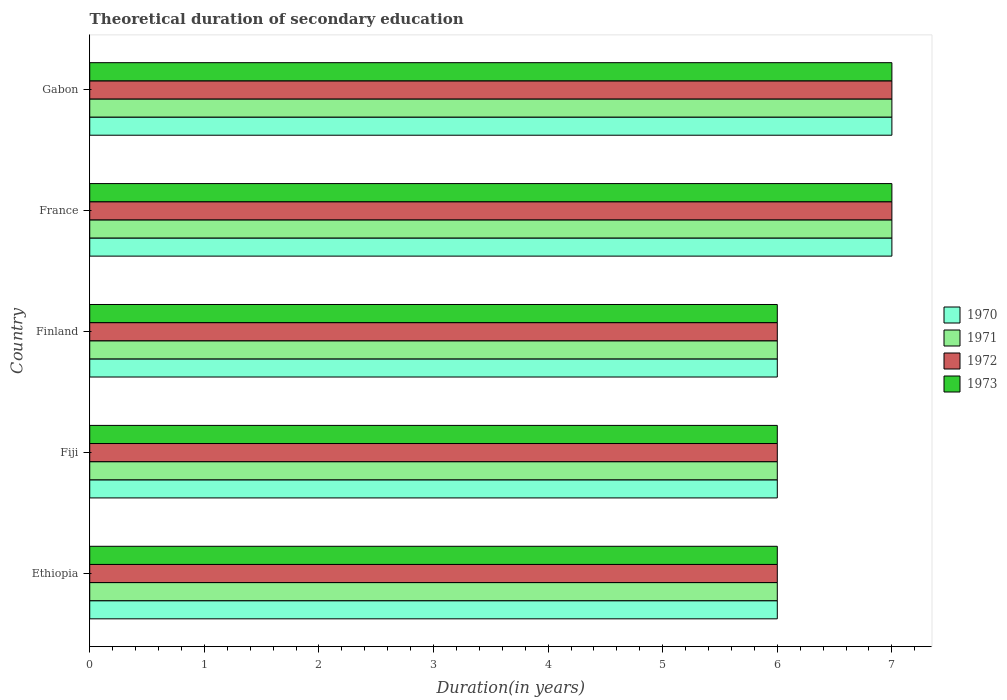How many groups of bars are there?
Your answer should be very brief. 5. Are the number of bars per tick equal to the number of legend labels?
Offer a very short reply. Yes. Are the number of bars on each tick of the Y-axis equal?
Offer a terse response. Yes. What is the label of the 5th group of bars from the top?
Your response must be concise. Ethiopia. Across all countries, what is the maximum total theoretical duration of secondary education in 1970?
Ensure brevity in your answer.  7. Across all countries, what is the minimum total theoretical duration of secondary education in 1972?
Keep it short and to the point. 6. In which country was the total theoretical duration of secondary education in 1972 maximum?
Ensure brevity in your answer.  France. In which country was the total theoretical duration of secondary education in 1970 minimum?
Give a very brief answer. Ethiopia. What is the total total theoretical duration of secondary education in 1970 in the graph?
Ensure brevity in your answer.  32. What is the average total theoretical duration of secondary education in 1972 per country?
Give a very brief answer. 6.4. What is the ratio of the total theoretical duration of secondary education in 1973 in Finland to that in Gabon?
Offer a terse response. 0.86. What is the difference between the highest and the second highest total theoretical duration of secondary education in 1973?
Keep it short and to the point. 0. In how many countries, is the total theoretical duration of secondary education in 1971 greater than the average total theoretical duration of secondary education in 1971 taken over all countries?
Provide a succinct answer. 2. How many bars are there?
Your response must be concise. 20. Are all the bars in the graph horizontal?
Offer a terse response. Yes. How many countries are there in the graph?
Provide a succinct answer. 5. Are the values on the major ticks of X-axis written in scientific E-notation?
Make the answer very short. No. Does the graph contain grids?
Offer a terse response. No. How many legend labels are there?
Make the answer very short. 4. What is the title of the graph?
Your answer should be compact. Theoretical duration of secondary education. What is the label or title of the X-axis?
Keep it short and to the point. Duration(in years). What is the label or title of the Y-axis?
Make the answer very short. Country. What is the Duration(in years) of 1971 in Ethiopia?
Your answer should be compact. 6. What is the Duration(in years) of 1972 in Ethiopia?
Your answer should be very brief. 6. What is the Duration(in years) in 1973 in Ethiopia?
Make the answer very short. 6. What is the Duration(in years) in 1970 in Fiji?
Keep it short and to the point. 6. What is the Duration(in years) in 1971 in Fiji?
Your answer should be very brief. 6. What is the Duration(in years) of 1972 in Fiji?
Ensure brevity in your answer.  6. What is the Duration(in years) in 1971 in Finland?
Provide a short and direct response. 6. What is the Duration(in years) in 1973 in Finland?
Your answer should be very brief. 6. What is the Duration(in years) in 1971 in France?
Provide a short and direct response. 7. What is the Duration(in years) of 1972 in France?
Your answer should be compact. 7. What is the Duration(in years) of 1970 in Gabon?
Make the answer very short. 7. What is the Duration(in years) of 1971 in Gabon?
Provide a short and direct response. 7. Across all countries, what is the maximum Duration(in years) of 1970?
Provide a succinct answer. 7. Across all countries, what is the maximum Duration(in years) in 1973?
Keep it short and to the point. 7. Across all countries, what is the minimum Duration(in years) of 1971?
Ensure brevity in your answer.  6. Across all countries, what is the minimum Duration(in years) of 1973?
Your response must be concise. 6. What is the total Duration(in years) in 1970 in the graph?
Your answer should be compact. 32. What is the difference between the Duration(in years) of 1972 in Ethiopia and that in Fiji?
Provide a short and direct response. 0. What is the difference between the Duration(in years) of 1971 in Ethiopia and that in Finland?
Offer a very short reply. 0. What is the difference between the Duration(in years) of 1973 in Ethiopia and that in Finland?
Your response must be concise. 0. What is the difference between the Duration(in years) of 1971 in Ethiopia and that in France?
Ensure brevity in your answer.  -1. What is the difference between the Duration(in years) in 1972 in Ethiopia and that in France?
Give a very brief answer. -1. What is the difference between the Duration(in years) of 1970 in Ethiopia and that in Gabon?
Keep it short and to the point. -1. What is the difference between the Duration(in years) in 1971 in Ethiopia and that in Gabon?
Keep it short and to the point. -1. What is the difference between the Duration(in years) of 1972 in Ethiopia and that in Gabon?
Provide a succinct answer. -1. What is the difference between the Duration(in years) of 1973 in Ethiopia and that in Gabon?
Offer a terse response. -1. What is the difference between the Duration(in years) of 1971 in Fiji and that in Finland?
Offer a very short reply. 0. What is the difference between the Duration(in years) of 1972 in Fiji and that in Finland?
Ensure brevity in your answer.  0. What is the difference between the Duration(in years) in 1973 in Fiji and that in Finland?
Provide a succinct answer. 0. What is the difference between the Duration(in years) of 1970 in Fiji and that in France?
Ensure brevity in your answer.  -1. What is the difference between the Duration(in years) in 1971 in Fiji and that in France?
Your answer should be very brief. -1. What is the difference between the Duration(in years) of 1973 in Fiji and that in France?
Give a very brief answer. -1. What is the difference between the Duration(in years) in 1971 in Fiji and that in Gabon?
Give a very brief answer. -1. What is the difference between the Duration(in years) of 1970 in Finland and that in France?
Your answer should be compact. -1. What is the difference between the Duration(in years) of 1971 in Finland and that in France?
Provide a succinct answer. -1. What is the difference between the Duration(in years) in 1972 in Finland and that in France?
Provide a short and direct response. -1. What is the difference between the Duration(in years) of 1973 in Finland and that in France?
Offer a terse response. -1. What is the difference between the Duration(in years) in 1972 in Finland and that in Gabon?
Ensure brevity in your answer.  -1. What is the difference between the Duration(in years) of 1973 in Finland and that in Gabon?
Keep it short and to the point. -1. What is the difference between the Duration(in years) of 1970 in France and that in Gabon?
Keep it short and to the point. 0. What is the difference between the Duration(in years) of 1972 in France and that in Gabon?
Provide a succinct answer. 0. What is the difference between the Duration(in years) in 1970 in Ethiopia and the Duration(in years) in 1971 in Fiji?
Your answer should be compact. 0. What is the difference between the Duration(in years) of 1970 in Ethiopia and the Duration(in years) of 1972 in Fiji?
Offer a terse response. 0. What is the difference between the Duration(in years) in 1970 in Ethiopia and the Duration(in years) in 1973 in Fiji?
Make the answer very short. 0. What is the difference between the Duration(in years) of 1971 in Ethiopia and the Duration(in years) of 1972 in Fiji?
Keep it short and to the point. 0. What is the difference between the Duration(in years) of 1970 in Ethiopia and the Duration(in years) of 1973 in Finland?
Your answer should be very brief. 0. What is the difference between the Duration(in years) of 1970 in Ethiopia and the Duration(in years) of 1971 in France?
Make the answer very short. -1. What is the difference between the Duration(in years) of 1970 in Ethiopia and the Duration(in years) of 1972 in France?
Give a very brief answer. -1. What is the difference between the Duration(in years) of 1971 in Ethiopia and the Duration(in years) of 1973 in France?
Ensure brevity in your answer.  -1. What is the difference between the Duration(in years) in 1972 in Ethiopia and the Duration(in years) in 1973 in France?
Provide a succinct answer. -1. What is the difference between the Duration(in years) of 1970 in Ethiopia and the Duration(in years) of 1971 in Gabon?
Offer a very short reply. -1. What is the difference between the Duration(in years) in 1971 in Ethiopia and the Duration(in years) in 1972 in Gabon?
Your answer should be very brief. -1. What is the difference between the Duration(in years) in 1972 in Ethiopia and the Duration(in years) in 1973 in Gabon?
Give a very brief answer. -1. What is the difference between the Duration(in years) of 1970 in Fiji and the Duration(in years) of 1972 in Finland?
Offer a very short reply. 0. What is the difference between the Duration(in years) of 1970 in Fiji and the Duration(in years) of 1973 in Finland?
Offer a terse response. 0. What is the difference between the Duration(in years) of 1971 in Fiji and the Duration(in years) of 1972 in Finland?
Provide a short and direct response. 0. What is the difference between the Duration(in years) of 1971 in Fiji and the Duration(in years) of 1973 in Finland?
Offer a terse response. 0. What is the difference between the Duration(in years) in 1970 in Fiji and the Duration(in years) in 1973 in France?
Provide a succinct answer. -1. What is the difference between the Duration(in years) of 1970 in Finland and the Duration(in years) of 1971 in France?
Provide a succinct answer. -1. What is the difference between the Duration(in years) of 1970 in Finland and the Duration(in years) of 1972 in France?
Your answer should be compact. -1. What is the difference between the Duration(in years) of 1970 in Finland and the Duration(in years) of 1973 in France?
Make the answer very short. -1. What is the difference between the Duration(in years) in 1970 in Finland and the Duration(in years) in 1971 in Gabon?
Provide a short and direct response. -1. What is the difference between the Duration(in years) in 1971 in Finland and the Duration(in years) in 1973 in Gabon?
Your response must be concise. -1. What is the difference between the Duration(in years) in 1972 in Finland and the Duration(in years) in 1973 in Gabon?
Ensure brevity in your answer.  -1. What is the difference between the Duration(in years) of 1970 in France and the Duration(in years) of 1971 in Gabon?
Make the answer very short. 0. What is the difference between the Duration(in years) of 1970 in France and the Duration(in years) of 1972 in Gabon?
Your answer should be compact. 0. What is the difference between the Duration(in years) in 1970 in France and the Duration(in years) in 1973 in Gabon?
Ensure brevity in your answer.  0. What is the difference between the Duration(in years) of 1971 in France and the Duration(in years) of 1972 in Gabon?
Your response must be concise. 0. What is the difference between the Duration(in years) of 1971 in France and the Duration(in years) of 1973 in Gabon?
Your answer should be very brief. 0. What is the average Duration(in years) in 1972 per country?
Make the answer very short. 6.4. What is the difference between the Duration(in years) of 1970 and Duration(in years) of 1973 in Ethiopia?
Offer a terse response. 0. What is the difference between the Duration(in years) of 1971 and Duration(in years) of 1972 in Ethiopia?
Your response must be concise. 0. What is the difference between the Duration(in years) in 1971 and Duration(in years) in 1972 in Fiji?
Offer a very short reply. 0. What is the difference between the Duration(in years) of 1971 and Duration(in years) of 1973 in Fiji?
Make the answer very short. 0. What is the difference between the Duration(in years) of 1972 and Duration(in years) of 1973 in Fiji?
Give a very brief answer. 0. What is the difference between the Duration(in years) of 1970 and Duration(in years) of 1971 in Finland?
Your response must be concise. 0. What is the difference between the Duration(in years) of 1971 and Duration(in years) of 1972 in Finland?
Your answer should be compact. 0. What is the difference between the Duration(in years) in 1971 and Duration(in years) in 1973 in Finland?
Ensure brevity in your answer.  0. What is the difference between the Duration(in years) of 1972 and Duration(in years) of 1973 in Finland?
Provide a succinct answer. 0. What is the difference between the Duration(in years) of 1970 and Duration(in years) of 1971 in France?
Provide a short and direct response. 0. What is the difference between the Duration(in years) of 1970 and Duration(in years) of 1972 in France?
Offer a terse response. 0. What is the difference between the Duration(in years) of 1970 and Duration(in years) of 1973 in France?
Offer a terse response. 0. What is the difference between the Duration(in years) of 1971 and Duration(in years) of 1972 in France?
Offer a very short reply. 0. What is the difference between the Duration(in years) of 1970 and Duration(in years) of 1971 in Gabon?
Offer a terse response. 0. What is the difference between the Duration(in years) of 1970 and Duration(in years) of 1973 in Gabon?
Your answer should be compact. 0. What is the difference between the Duration(in years) of 1971 and Duration(in years) of 1972 in Gabon?
Your answer should be compact. 0. What is the difference between the Duration(in years) of 1971 and Duration(in years) of 1973 in Gabon?
Provide a succinct answer. 0. What is the difference between the Duration(in years) in 1972 and Duration(in years) in 1973 in Gabon?
Your answer should be compact. 0. What is the ratio of the Duration(in years) in 1972 in Ethiopia to that in Finland?
Provide a short and direct response. 1. What is the ratio of the Duration(in years) of 1973 in Ethiopia to that in Finland?
Provide a succinct answer. 1. What is the ratio of the Duration(in years) in 1971 in Ethiopia to that in France?
Ensure brevity in your answer.  0.86. What is the ratio of the Duration(in years) in 1970 in Ethiopia to that in Gabon?
Offer a very short reply. 0.86. What is the ratio of the Duration(in years) in 1971 in Ethiopia to that in Gabon?
Your answer should be very brief. 0.86. What is the ratio of the Duration(in years) in 1973 in Ethiopia to that in Gabon?
Offer a very short reply. 0.86. What is the ratio of the Duration(in years) of 1973 in Fiji to that in Finland?
Your response must be concise. 1. What is the ratio of the Duration(in years) of 1973 in Fiji to that in France?
Offer a very short reply. 0.86. What is the ratio of the Duration(in years) in 1971 in Fiji to that in Gabon?
Your answer should be very brief. 0.86. What is the ratio of the Duration(in years) in 1972 in Fiji to that in Gabon?
Give a very brief answer. 0.86. What is the ratio of the Duration(in years) of 1973 in Finland to that in France?
Ensure brevity in your answer.  0.86. What is the ratio of the Duration(in years) of 1970 in Finland to that in Gabon?
Offer a very short reply. 0.86. What is the ratio of the Duration(in years) in 1970 in France to that in Gabon?
Your response must be concise. 1. What is the ratio of the Duration(in years) in 1973 in France to that in Gabon?
Offer a very short reply. 1. What is the difference between the highest and the second highest Duration(in years) of 1970?
Your response must be concise. 0. What is the difference between the highest and the second highest Duration(in years) in 1971?
Your answer should be compact. 0. What is the difference between the highest and the second highest Duration(in years) of 1973?
Your response must be concise. 0. What is the difference between the highest and the lowest Duration(in years) of 1970?
Make the answer very short. 1. What is the difference between the highest and the lowest Duration(in years) of 1971?
Ensure brevity in your answer.  1. What is the difference between the highest and the lowest Duration(in years) in 1973?
Your answer should be compact. 1. 